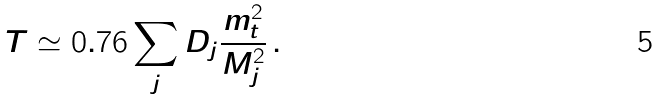Convert formula to latex. <formula><loc_0><loc_0><loc_500><loc_500>T \simeq 0 . 7 6 \sum _ { j } D _ { j } \frac { m _ { t } ^ { 2 } } { M _ { j } ^ { 2 } } \, .</formula> 